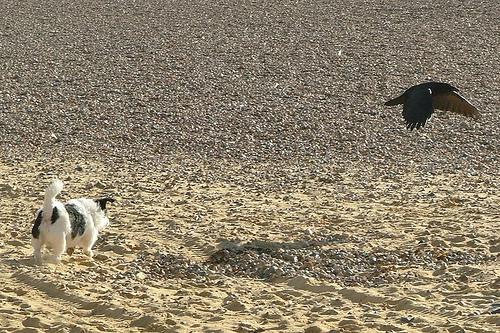Question: what type of scene is this?
Choices:
A. Nativity.
B. Outdoor.
C. Indoor.
D. Movie.
Answer with the letter. Answer: B Question: who are in the photo?
Choices:
A. Superheroes.
B. Soldiers.
C. Doctors.
D. No one.
Answer with the letter. Answer: D Question: what is the weather?
Choices:
A. Raining.
B. Sunny.
C. Sleet.
D. Snow.
Answer with the letter. Answer: B Question: what is in air?
Choices:
A. Clouds.
B. Plane.
C. Skydiver.
D. A bird.
Answer with the letter. Answer: D 